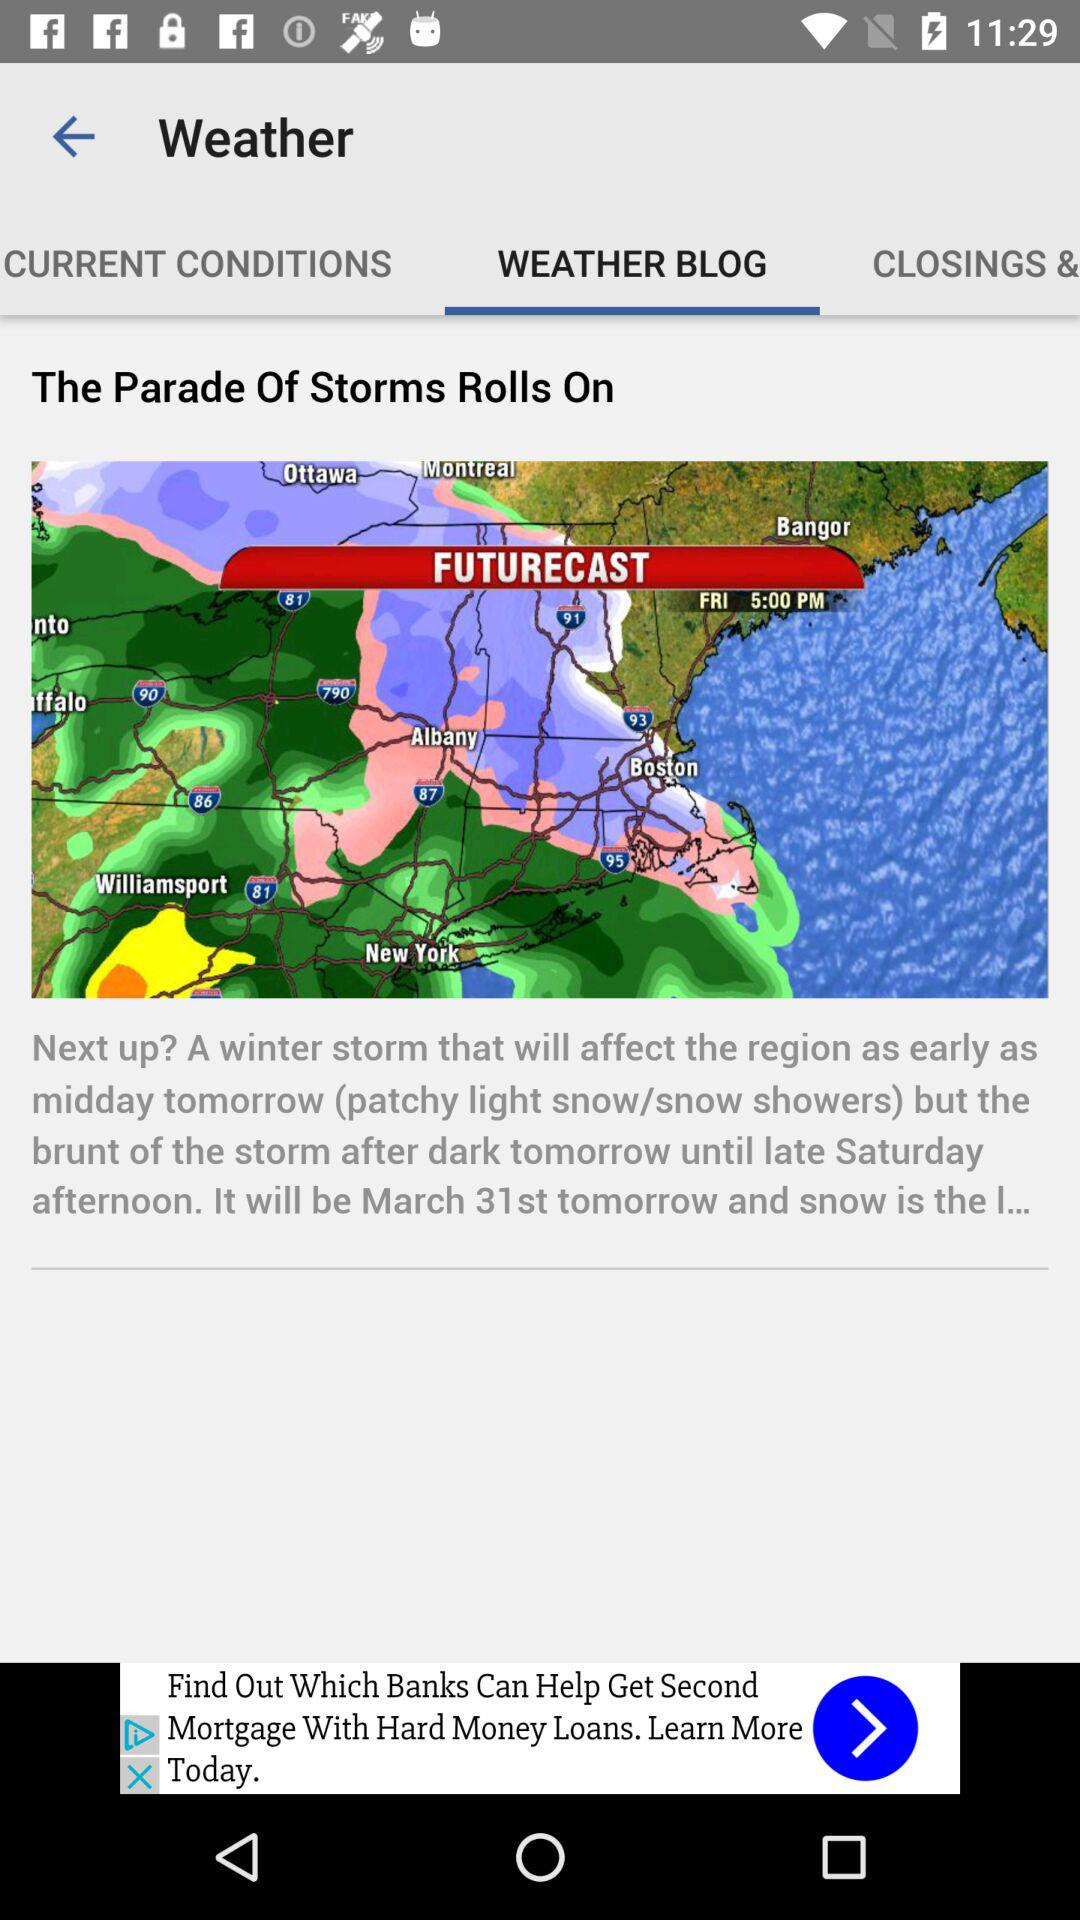On which tab are we? You are on the "WEATHER BLOG" tab. 